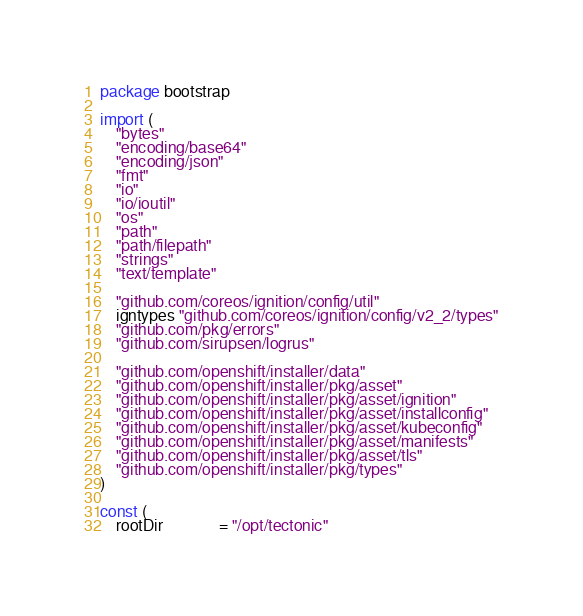<code> <loc_0><loc_0><loc_500><loc_500><_Go_>package bootstrap

import (
	"bytes"
	"encoding/base64"
	"encoding/json"
	"fmt"
	"io"
	"io/ioutil"
	"os"
	"path"
	"path/filepath"
	"strings"
	"text/template"

	"github.com/coreos/ignition/config/util"
	igntypes "github.com/coreos/ignition/config/v2_2/types"
	"github.com/pkg/errors"
	"github.com/sirupsen/logrus"

	"github.com/openshift/installer/data"
	"github.com/openshift/installer/pkg/asset"
	"github.com/openshift/installer/pkg/asset/ignition"
	"github.com/openshift/installer/pkg/asset/installconfig"
	"github.com/openshift/installer/pkg/asset/kubeconfig"
	"github.com/openshift/installer/pkg/asset/manifests"
	"github.com/openshift/installer/pkg/asset/tls"
	"github.com/openshift/installer/pkg/types"
)

const (
	rootDir              = "/opt/tectonic"</code> 